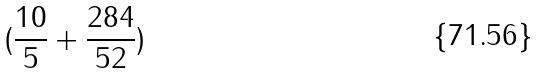Convert formula to latex. <formula><loc_0><loc_0><loc_500><loc_500>( \frac { 1 0 } { 5 } + \frac { 2 8 4 } { 5 2 } )</formula> 